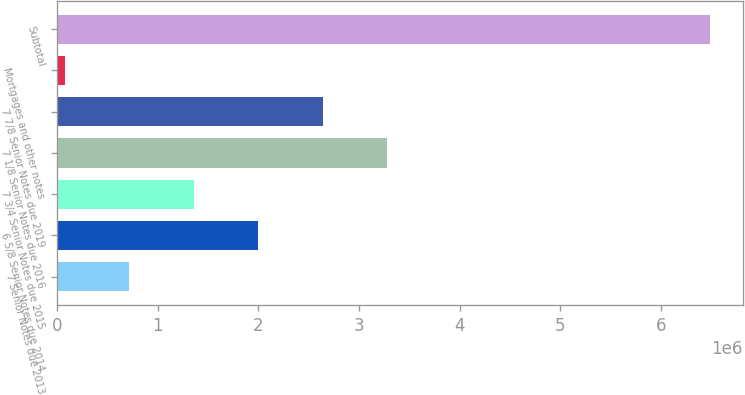<chart> <loc_0><loc_0><loc_500><loc_500><bar_chart><fcel>7 Senior Notes due 2013<fcel>6 5/8 Senior Notes due 2014<fcel>7 3/4 Senior Notes due 2015<fcel>7 1/8 Senior Notes due 2016<fcel>7 7/8 Senior Notes due 2019<fcel>Mortgages and other notes<fcel>Subtotal<nl><fcel>718782<fcel>2.00041e+06<fcel>1.3596e+06<fcel>3.28205e+06<fcel>2.64123e+06<fcel>77965<fcel>6.48613e+06<nl></chart> 